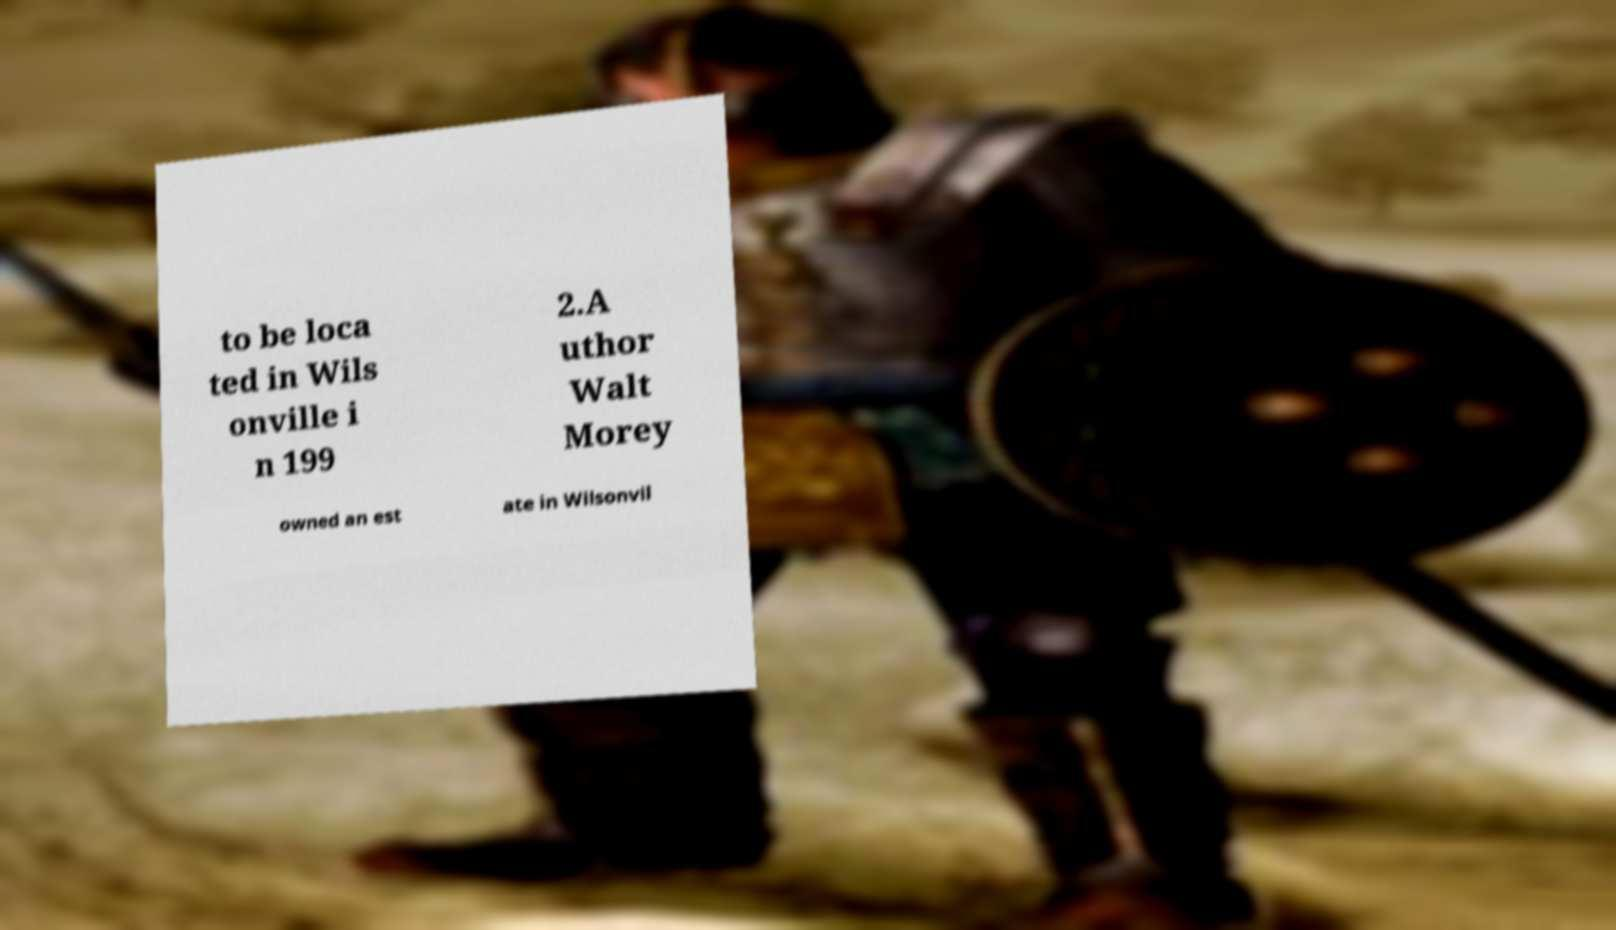Can you accurately transcribe the text from the provided image for me? to be loca ted in Wils onville i n 199 2.A uthor Walt Morey owned an est ate in Wilsonvil 